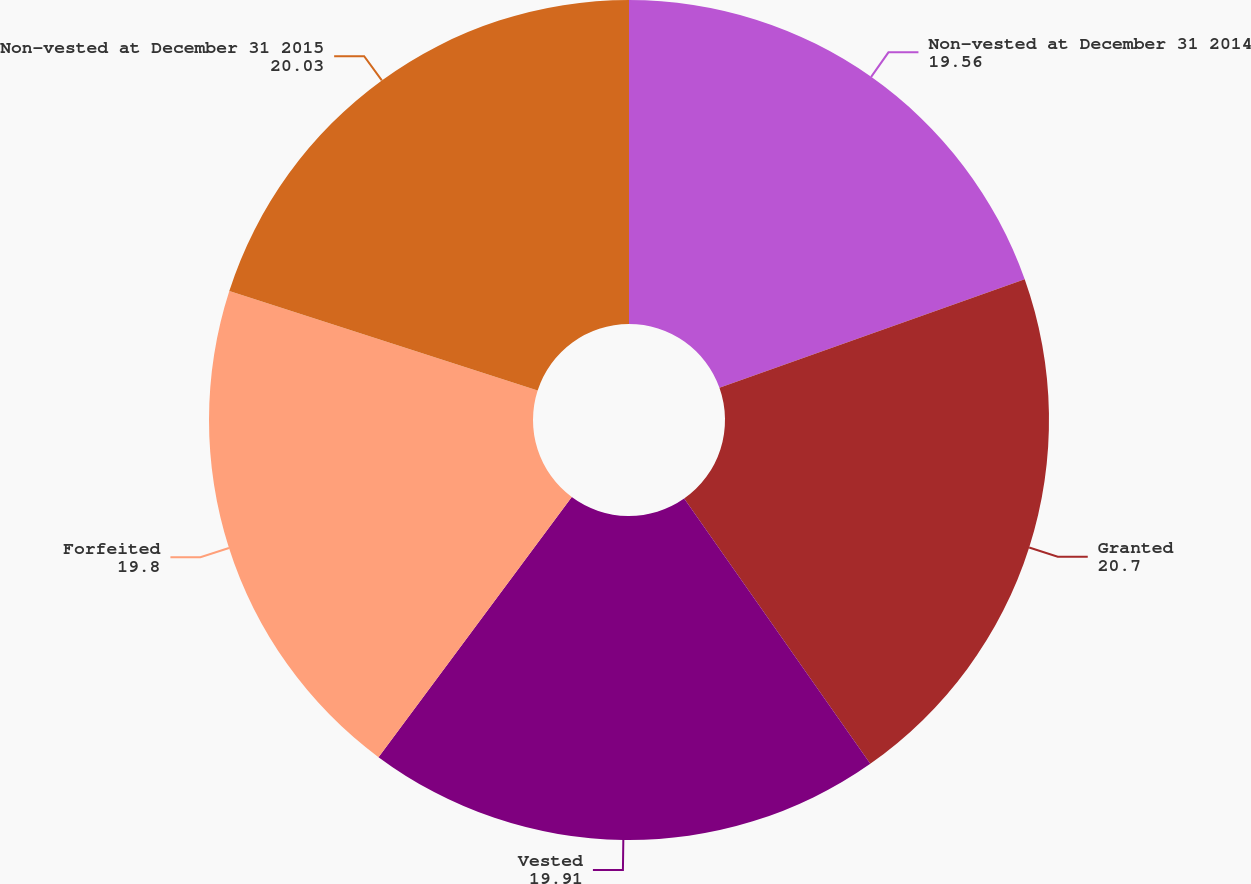Convert chart. <chart><loc_0><loc_0><loc_500><loc_500><pie_chart><fcel>Non-vested at December 31 2014<fcel>Granted<fcel>Vested<fcel>Forfeited<fcel>Non-vested at December 31 2015<nl><fcel>19.56%<fcel>20.7%<fcel>19.91%<fcel>19.8%<fcel>20.03%<nl></chart> 